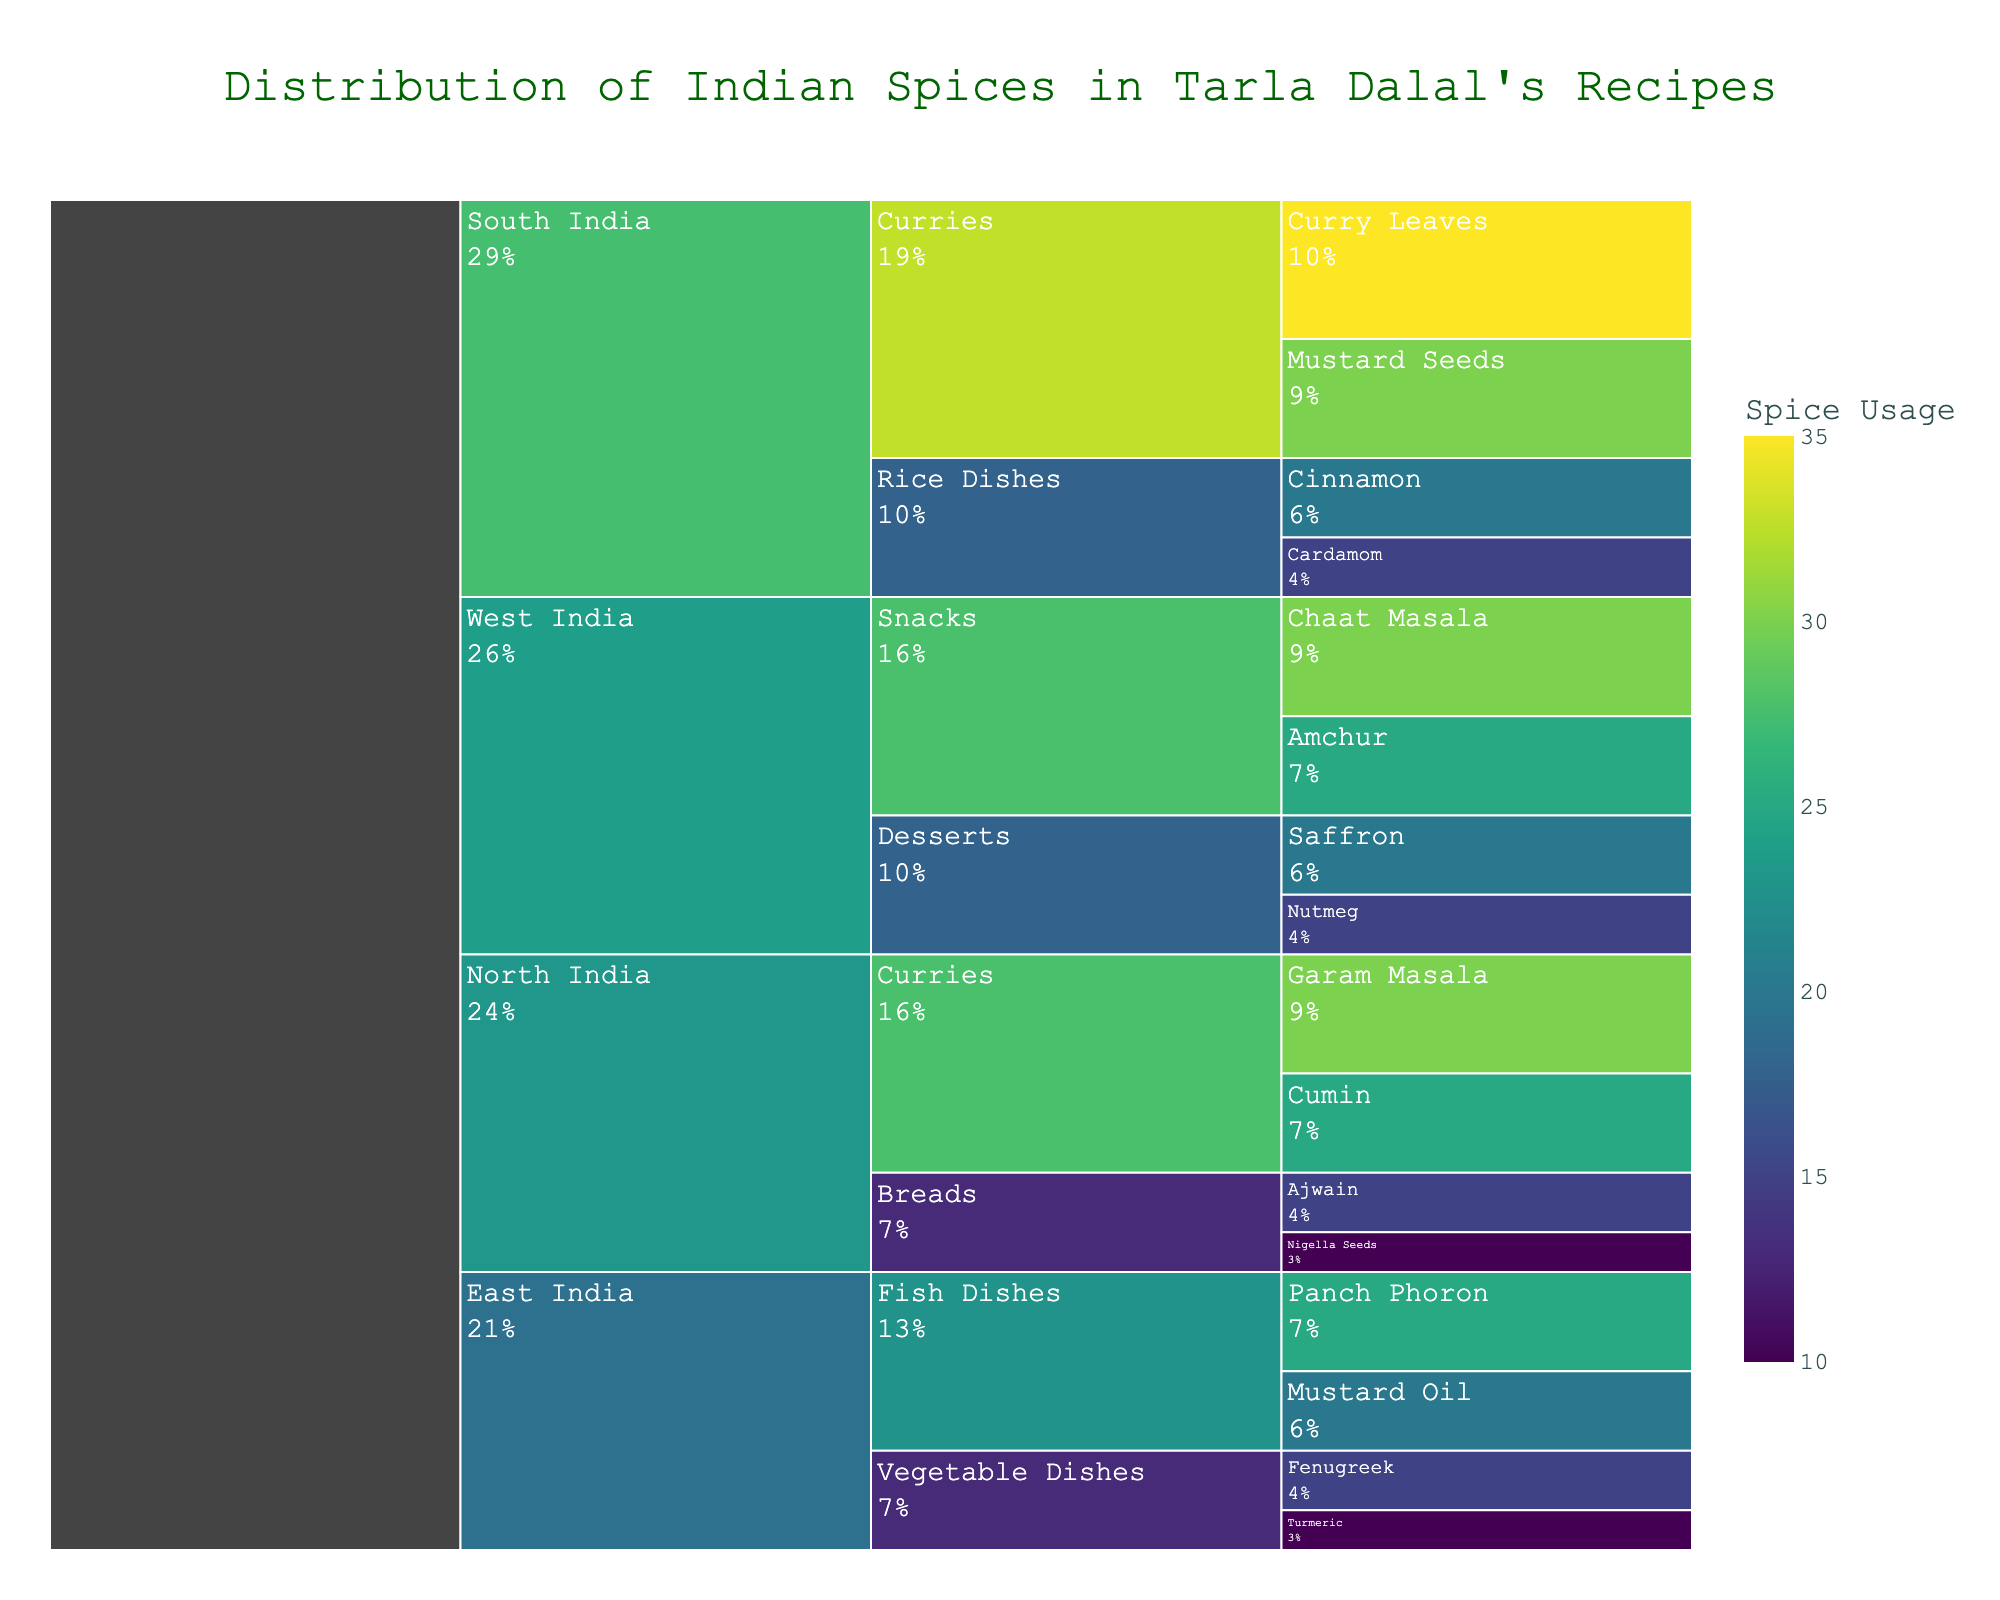What is the title of the icicle chart? The title is displayed at the top center of the chart in a larger font size. It gives a brief description of what the chart represents.
Answer: Distribution of Indian Spices in Tarla Dalal's Recipes Which region has the highest total spice usage and what is that usage? The total spice usage for each region can be derived by summing up the usage values of all the spices within that region. By observing the icicle chart, South India shows the largest cumulative area, indicating the highest total usage. Adding up the values for South India: 35 (Curry Leaves) + 30 (Mustard Seeds) + 20 (Cinnamon) + 15 (Cardamom) = 100.
Answer: South India, 100 How much more spice does South India use for curries compared to North India? Look at the individual spice usage values for curries in both South India and North India. For South India: 35 (Curry Leaves) + 30 (Mustard Seeds) = 65. For North India: 30 (Garam Masala) + 25 (Cumin) = 55. Subtract the total for North India from South India: 65 - 55 = 10.
Answer: 10 Which spice has the highest usage in West India's snacks, and what is its usage? Within the West India region, look under the Snacks category for individual spices. Compare the usage values for each spice. Chaat Masala: 30, Amchur: 25. The highest value among them is Chaat Masala with 30.
Answer: Chaat Masala, 30 What is the combined usage of Ajwain and Nigella Seeds in North India? Ajwain and Nigella Seeds are found in the Breads category under North India. Add their usage values together: 15 (Ajwain) + 10 (Nigella Seeds) = 25.
Answer: 25 Which region uses the least amount of Cardamom, and what is that amount? Cardamom is used only in South India under the Rice Dishes category. Therefore, look at the usage directly.
Answer: South India, 15 How does the usage of Panch Phoron in East India's Fish Dishes compare to the usage of Fenugreek in East India's Vegetable Dishes? Look at the individual usage values. Panch Phoron: 25, Fenugreek: 15. Since 25 is greater than 15, Panch Phoron is used more.
Answer: Panch Phoron is used more What percentage of North India's spice usage in curries is contributed by Garam Masala? First, determine the total usage for curries in North India: 30 (Garam Masala) + 25 (Cumin) = 55. Then calculate the percentage contribution: (30 / 55) * 100 ≈ 54.55%.
Answer: 54.55% 